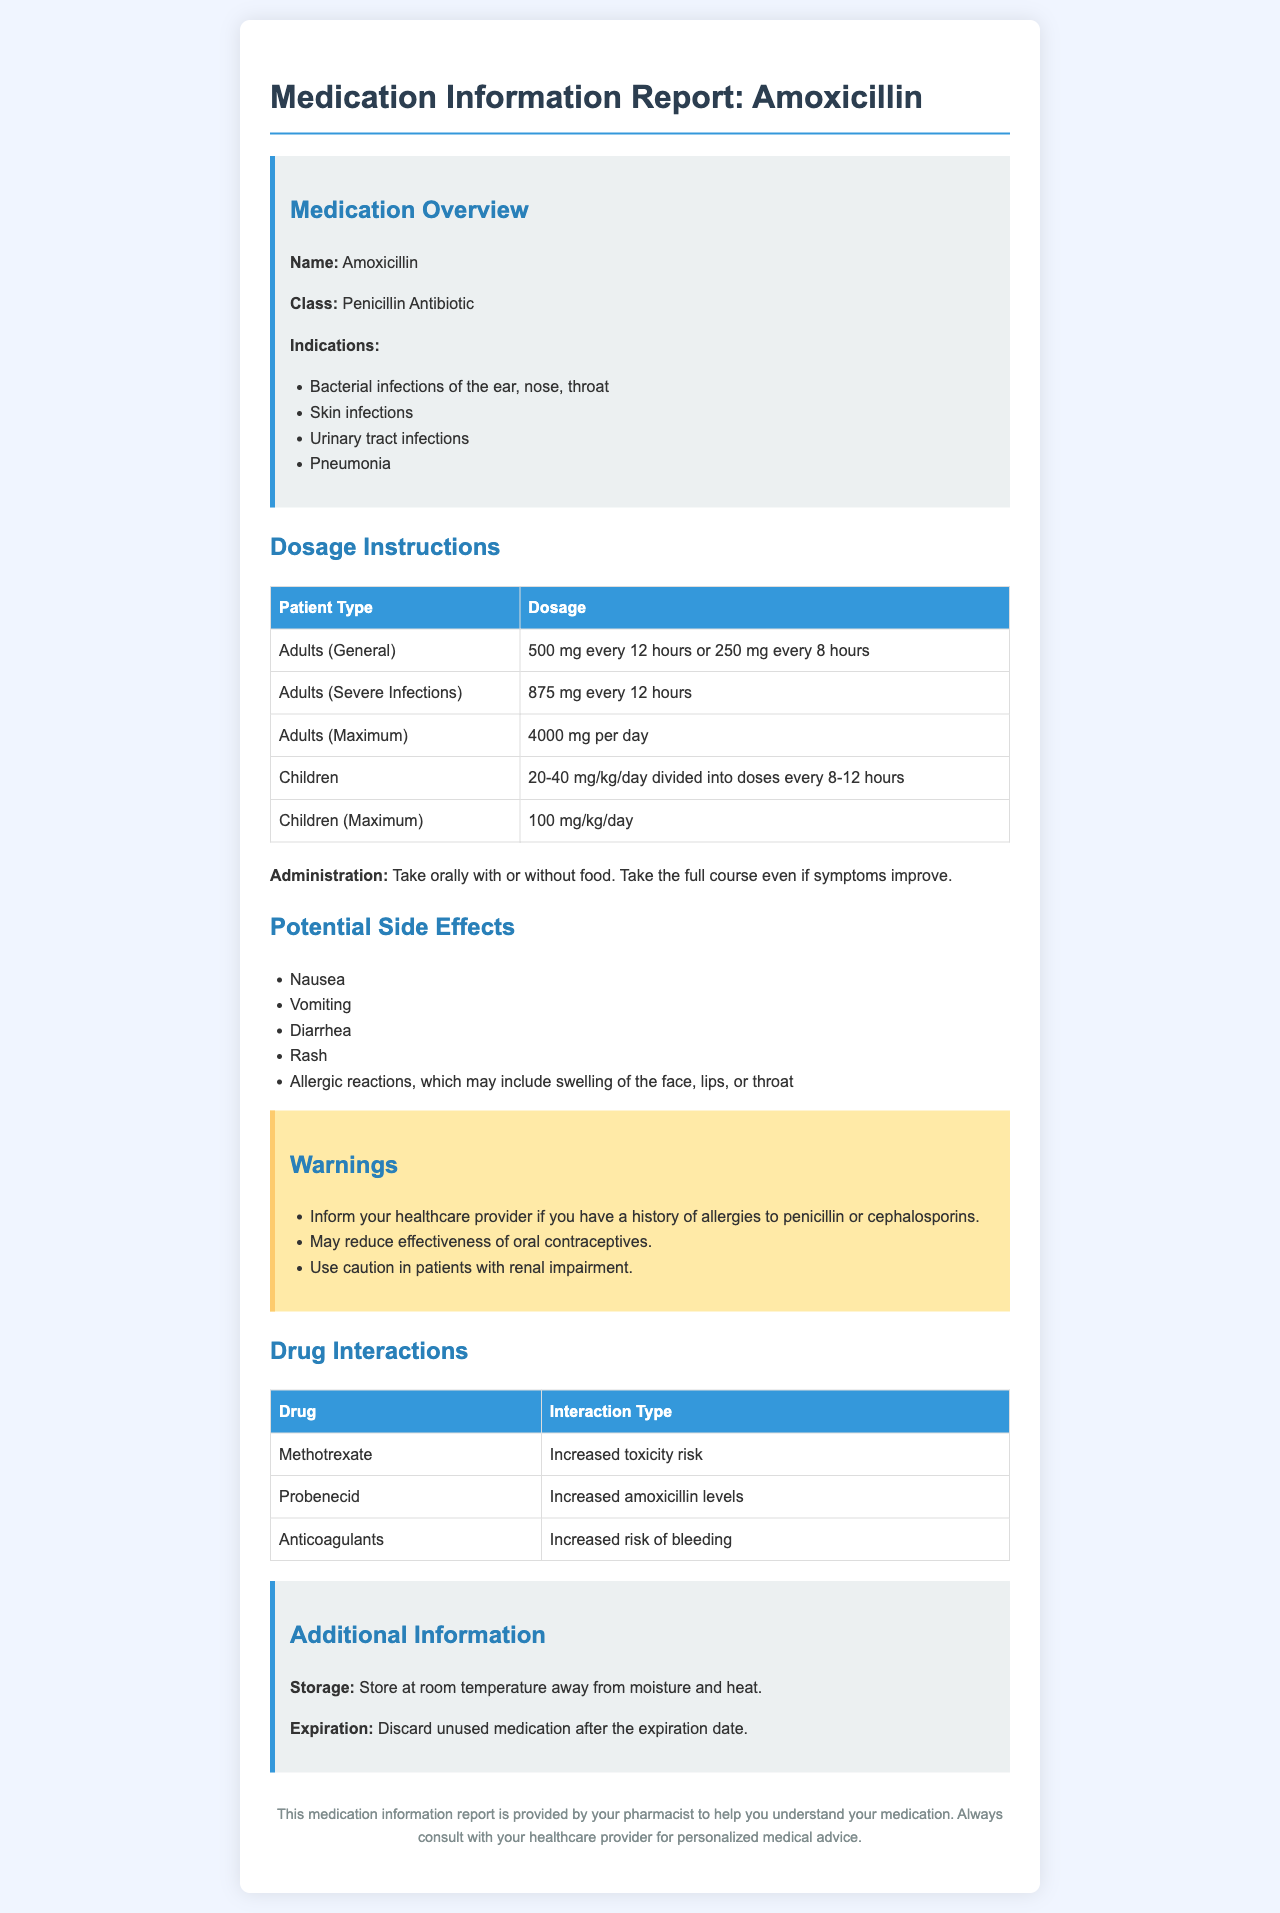What is the medication name? The medication name is explicitly stated in the report as "Amoxicillin."
Answer: Amoxicillin What is the dosage for adults with severe infections? The report specifies the dosage for adults with severe infections as "875 mg every 12 hours."
Answer: 875 mg every 12 hours What are two common potential side effects? The document lists potential side effects, including "Nausea" and "Vomiting."
Answer: Nausea, Vomiting What is the maximum daily dosage for children? The report provides the maximum daily dosage for children as "100 mg/kg/day."
Answer: 100 mg/kg/day Which drug increases the toxicity risk of methotrexate? The report identifies "Methotrexate" as having an increased toxicity risk when taken with amoxicillin.
Answer: Methotrexate What must you inform your healthcare provider about if you have allergies? The report states to inform your healthcare provider about "a history of allergies to penicillin or cephalosporins."
Answer: Allergies to penicillin or cephalosporins What is recommended regarding the course of medication? The document advises to "Take the full course even if symptoms improve."
Answer: Take the full course What is stated about storing the medication? The report mentions that the medication should "Store at room temperature away from moisture and heat."
Answer: Store at room temperature away from moisture and heat What should be done with unused medication past expiration? The document advises to "Discard unused medication after the expiration date."
Answer: Discard unused medication after the expiration date 